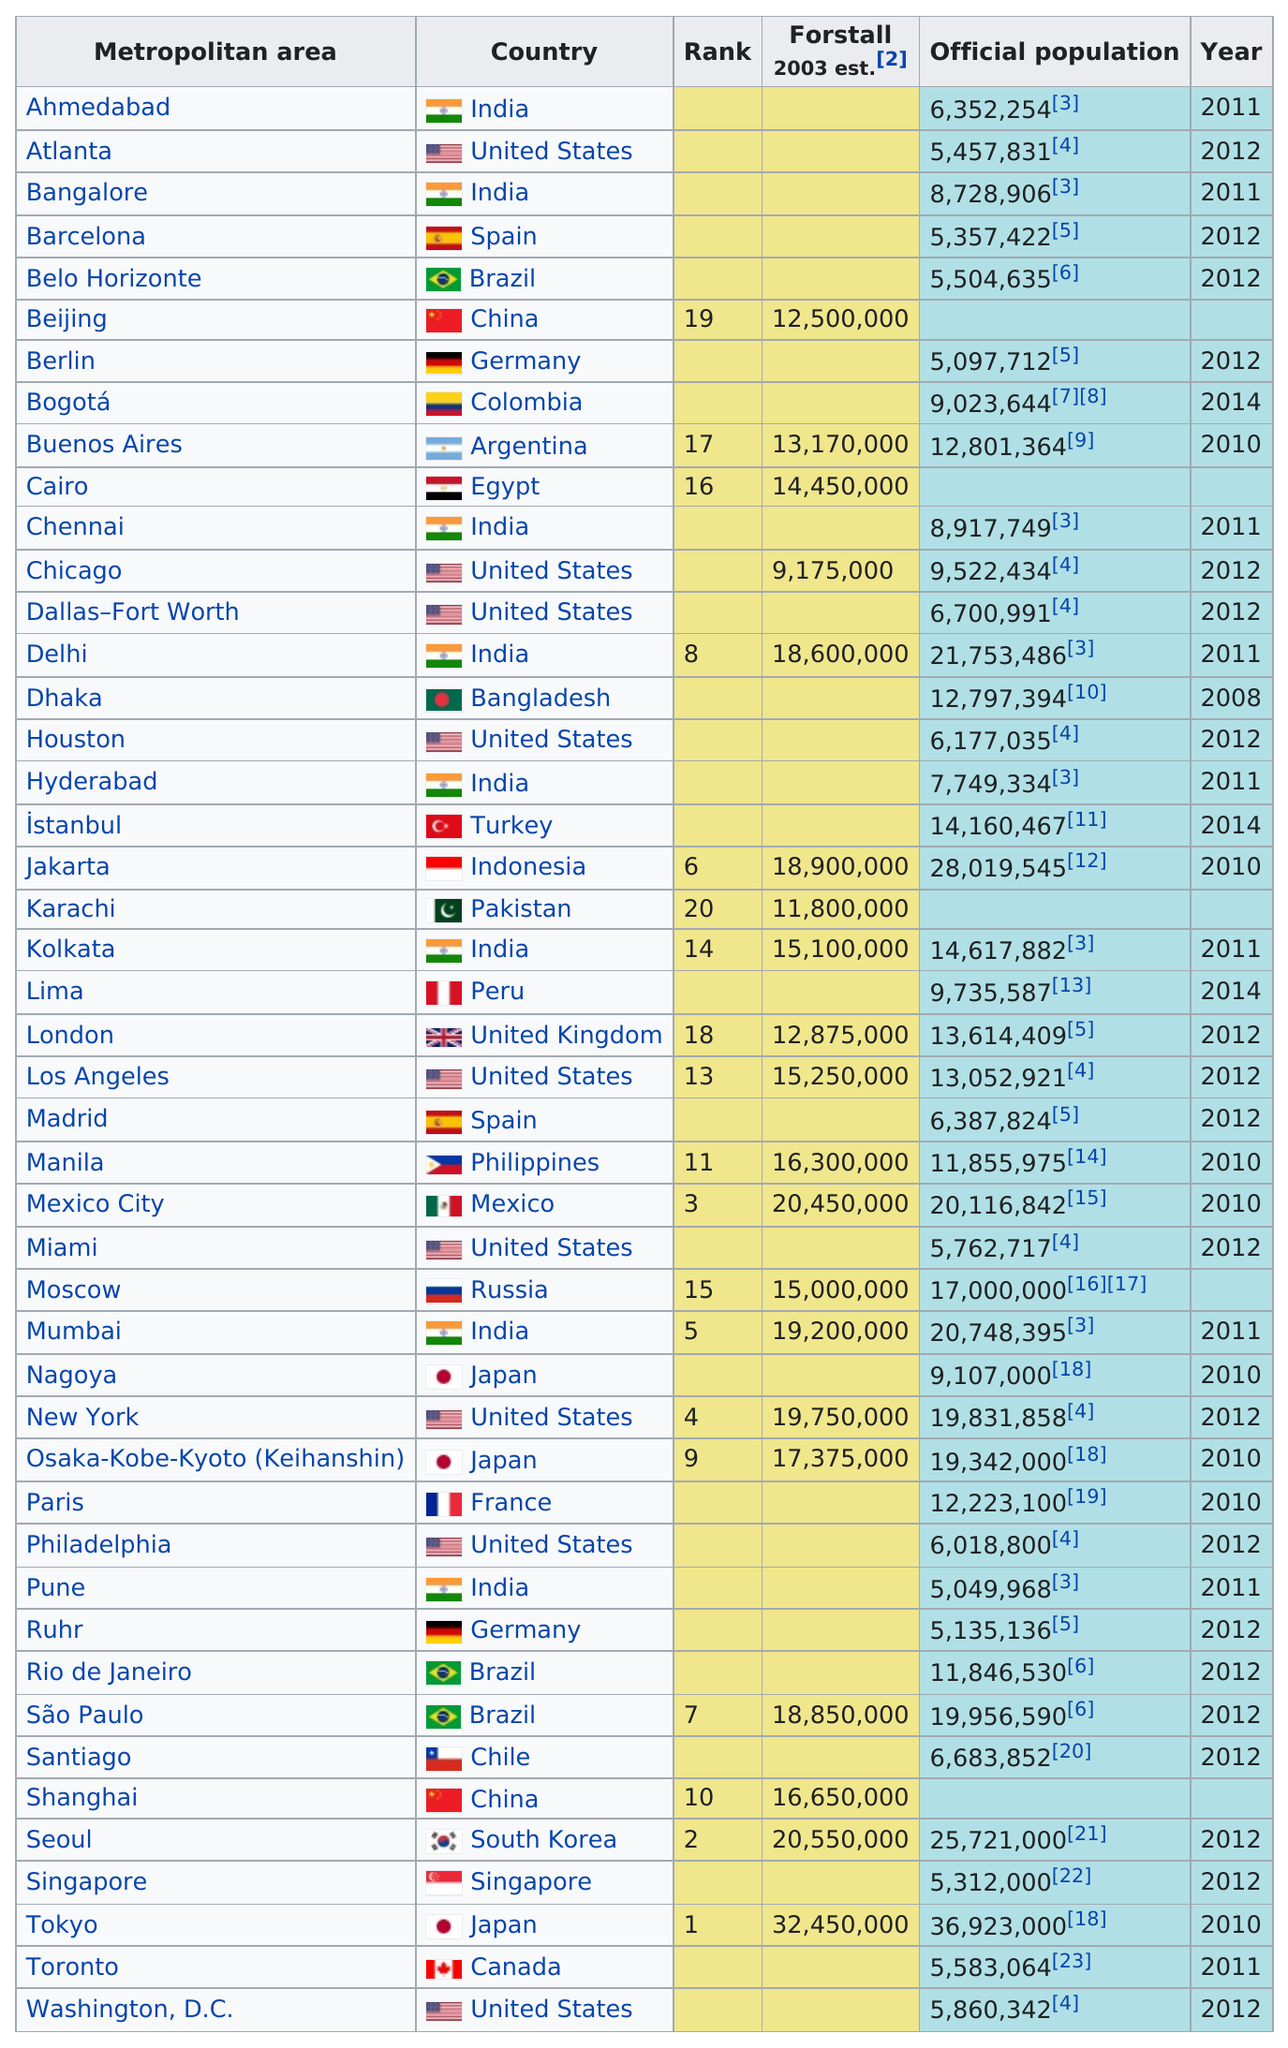Point out several critical features in this image. Buenos Aires, Dhaka, İstanbul, Kolkata, London, Los Angeles, Manila, Moscow, New York, Osaka-Kobe-Kyoto (Keihanshin), Paris, Rio de Janeiro, and São Paulo all had populations of more than 10,000,000 but less than 20,000,000. The city that was ranked first in 2003 was Tokyo. The years are not in a consecutive order. Chicago is located in the United States, while Chennai is located in India. It is important to note that Chennai is not located above Chicago. There are 9 cities in the United States. 